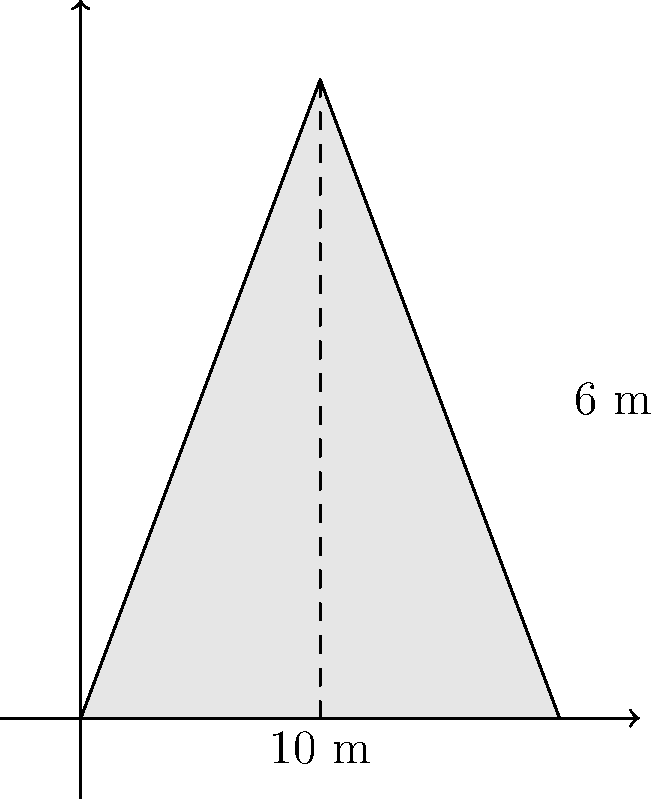At an archaeological site in Seychelles, you encounter a conical mound that is believed to be an ancient burial structure. The mound has a circular base with a radius of 5 meters and a height of 6 meters. Estimate the volume of this conical mound to the nearest cubic meter. To estimate the volume of the conical mound, we can use the formula for the volume of a cone:

$$V = \frac{1}{3} \pi r^2 h$$

Where:
$V$ = volume
$r$ = radius of the base
$h$ = height of the cone

Given:
- Radius (r) = 5 meters
- Height (h) = 6 meters

Step 1: Substitute the values into the formula:
$$V = \frac{1}{3} \pi (5\text{ m})^2 (6\text{ m})$$

Step 2: Calculate the square of the radius:
$$V = \frac{1}{3} \pi (25\text{ m}^2) (6\text{ m})$$

Step 3: Multiply the values:
$$V = \frac{1}{3} \pi (150\text{ m}^3)$$

Step 4: Multiply by π (use 3.14159 for π):
$$V = \frac{1}{3} (3.14159) (150\text{ m}^3) = 157.0795\text{ m}^3$$

Step 5: Round to the nearest cubic meter:
$$V \approx 157\text{ m}^3$$

Therefore, the estimated volume of the conical mound is approximately 157 cubic meters.
Answer: 157 m³ 